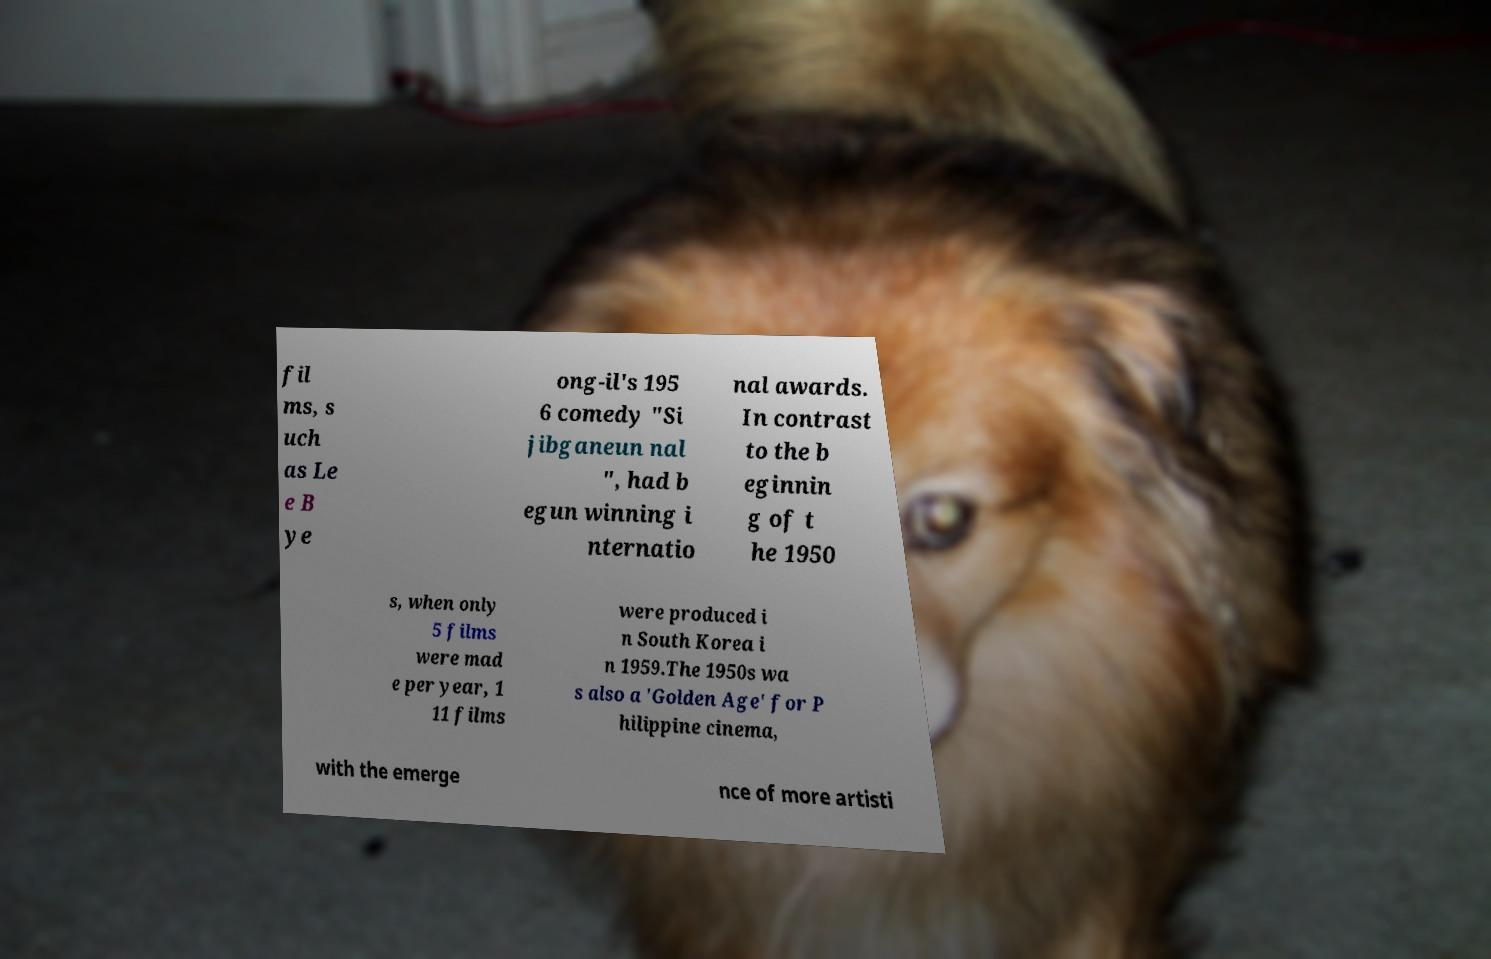What messages or text are displayed in this image? I need them in a readable, typed format. fil ms, s uch as Le e B ye ong-il's 195 6 comedy "Si jibganeun nal ", had b egun winning i nternatio nal awards. In contrast to the b eginnin g of t he 1950 s, when only 5 films were mad e per year, 1 11 films were produced i n South Korea i n 1959.The 1950s wa s also a 'Golden Age' for P hilippine cinema, with the emerge nce of more artisti 